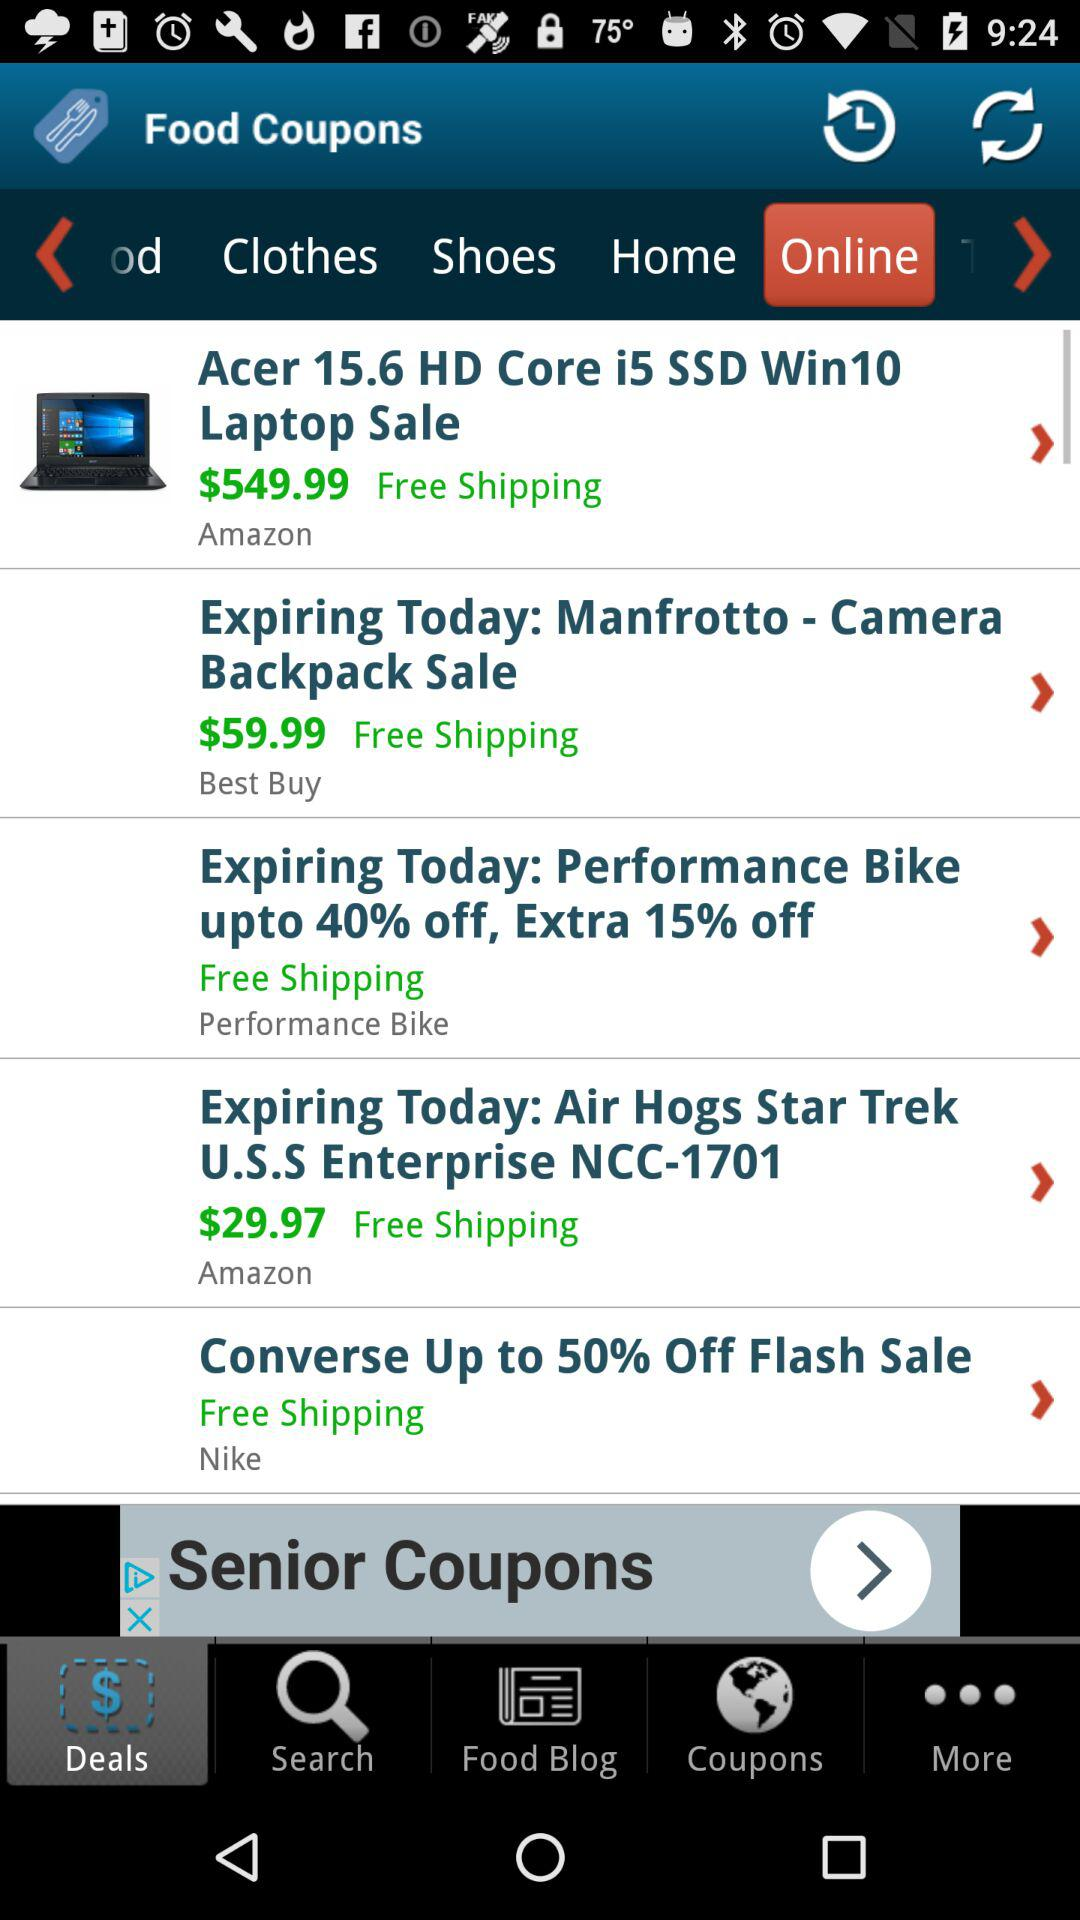What is the price of the "Camera Backpack" in the sale? The price of the "Camera Backpack" in the sale is $59.99. 